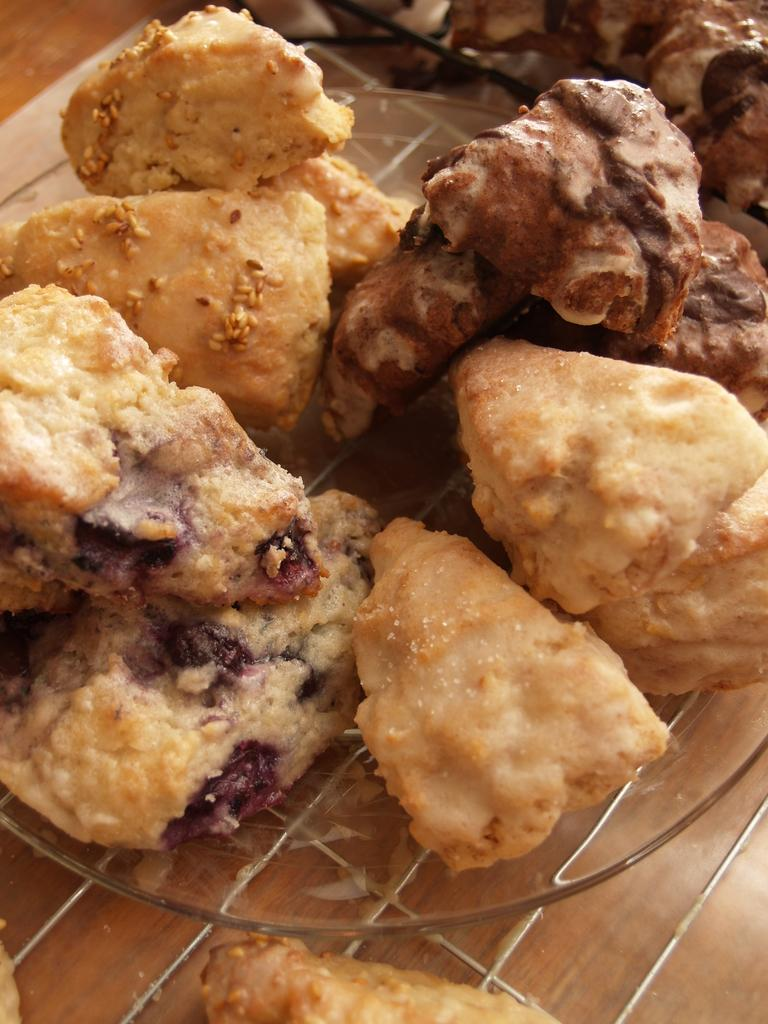What type of furniture is present in the image? There is a table in the image. What is placed on the table? There is a plate on the table. What is on the plate? There are bread pieces on the plate. How many card games are being played during the rainstorm in the image? There is no rainstorm or card games present in the image; it features a table with a plate and bread pieces. 